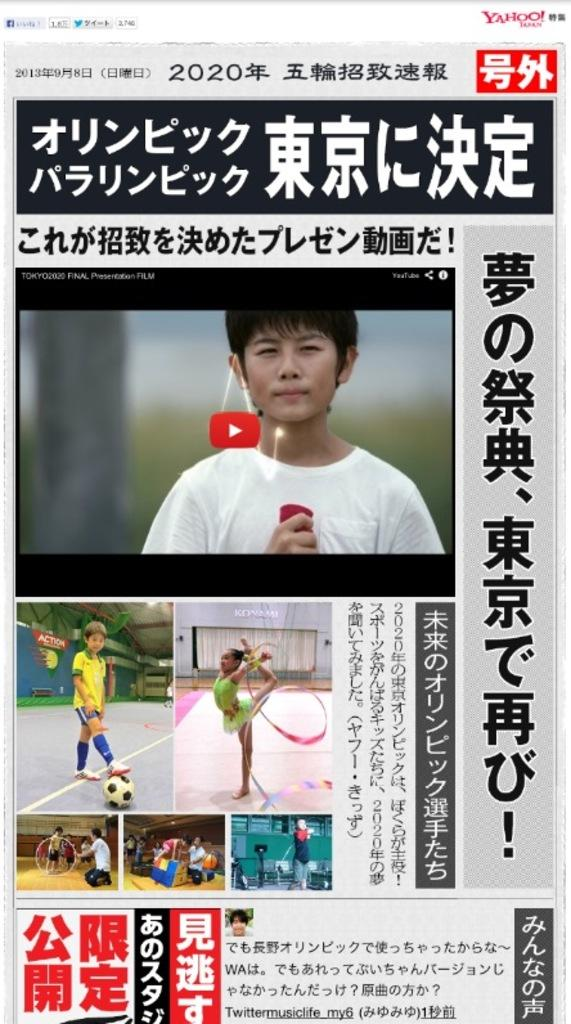What type of image is being described? The image is a poster. What can be seen in the pictures on the poster? There are pictures of people on the poster. What else is featured on the poster besides the images? There is text on the poster. Are there any plants growing out of the pipe in the image? There is no pipe or plants present in the image; it features a poster with pictures of people and text. 